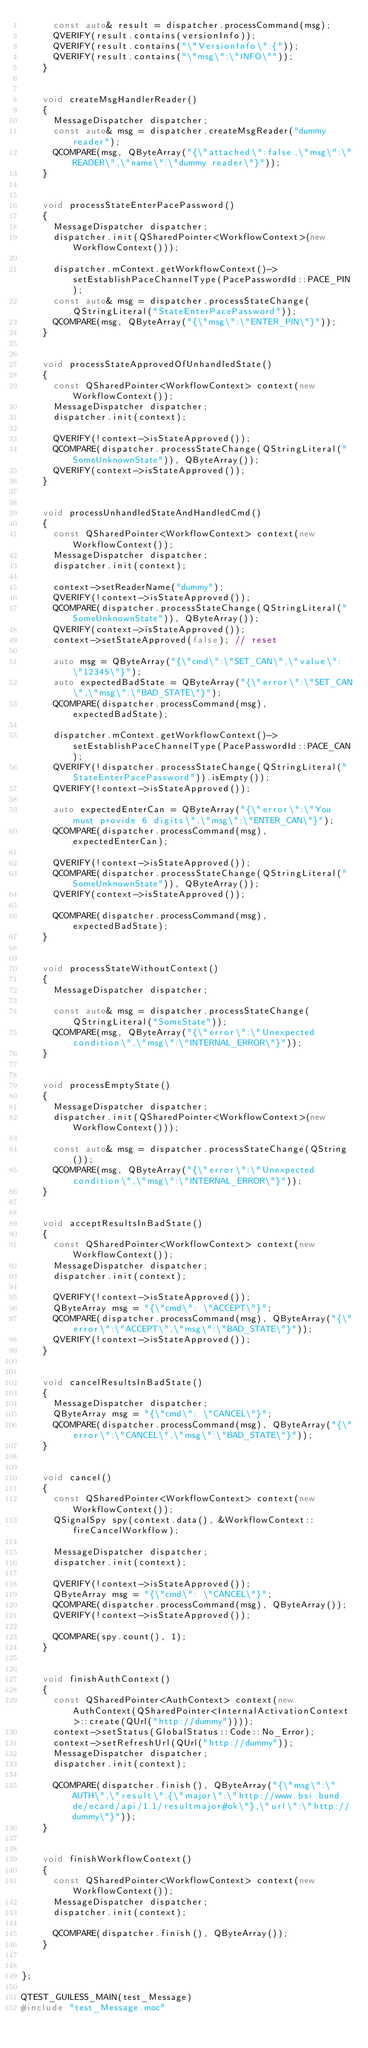<code> <loc_0><loc_0><loc_500><loc_500><_C++_>			const auto& result = dispatcher.processCommand(msg);
			QVERIFY(result.contains(versionInfo));
			QVERIFY(result.contains("\"VersionInfo\":{"));
			QVERIFY(result.contains("\"msg\":\"INFO\""));
		}


		void createMsgHandlerReader()
		{
			MessageDispatcher dispatcher;
			const auto& msg = dispatcher.createMsgReader("dummy reader");
			QCOMPARE(msg, QByteArray("{\"attached\":false,\"msg\":\"READER\",\"name\":\"dummy reader\"}"));
		}


		void processStateEnterPacePassword()
		{
			MessageDispatcher dispatcher;
			dispatcher.init(QSharedPointer<WorkflowContext>(new WorkflowContext()));

			dispatcher.mContext.getWorkflowContext()->setEstablishPaceChannelType(PacePasswordId::PACE_PIN);
			const auto& msg = dispatcher.processStateChange(QStringLiteral("StateEnterPacePassword"));
			QCOMPARE(msg, QByteArray("{\"msg\":\"ENTER_PIN\"}"));
		}


		void processStateApprovedOfUnhandledState()
		{
			const QSharedPointer<WorkflowContext> context(new WorkflowContext());
			MessageDispatcher dispatcher;
			dispatcher.init(context);

			QVERIFY(!context->isStateApproved());
			QCOMPARE(dispatcher.processStateChange(QStringLiteral("SomeUnknownState")), QByteArray());
			QVERIFY(context->isStateApproved());
		}


		void processUnhandledStateAndHandledCmd()
		{
			const QSharedPointer<WorkflowContext> context(new WorkflowContext());
			MessageDispatcher dispatcher;
			dispatcher.init(context);

			context->setReaderName("dummy");
			QVERIFY(!context->isStateApproved());
			QCOMPARE(dispatcher.processStateChange(QStringLiteral("SomeUnknownState")), QByteArray());
			QVERIFY(context->isStateApproved());
			context->setStateApproved(false); // reset

			auto msg = QByteArray("{\"cmd\":\"SET_CAN\",\"value\": \"12345\"}");
			auto expectedBadState = QByteArray("{\"error\":\"SET_CAN\",\"msg\":\"BAD_STATE\"}");
			QCOMPARE(dispatcher.processCommand(msg), expectedBadState);

			dispatcher.mContext.getWorkflowContext()->setEstablishPaceChannelType(PacePasswordId::PACE_CAN);
			QVERIFY(!dispatcher.processStateChange(QStringLiteral("StateEnterPacePassword")).isEmpty());
			QVERIFY(!context->isStateApproved());

			auto expectedEnterCan = QByteArray("{\"error\":\"You must provide 6 digits\",\"msg\":\"ENTER_CAN\"}");
			QCOMPARE(dispatcher.processCommand(msg), expectedEnterCan);

			QVERIFY(!context->isStateApproved());
			QCOMPARE(dispatcher.processStateChange(QStringLiteral("SomeUnknownState")), QByteArray());
			QVERIFY(context->isStateApproved());

			QCOMPARE(dispatcher.processCommand(msg), expectedBadState);
		}


		void processStateWithoutContext()
		{
			MessageDispatcher dispatcher;

			const auto& msg = dispatcher.processStateChange(QStringLiteral("SomeState"));
			QCOMPARE(msg, QByteArray("{\"error\":\"Unexpected condition\",\"msg\":\"INTERNAL_ERROR\"}"));
		}


		void processEmptyState()
		{
			MessageDispatcher dispatcher;
			dispatcher.init(QSharedPointer<WorkflowContext>(new WorkflowContext()));

			const auto& msg = dispatcher.processStateChange(QString());
			QCOMPARE(msg, QByteArray("{\"error\":\"Unexpected condition\",\"msg\":\"INTERNAL_ERROR\"}"));
		}


		void acceptResultsInBadState()
		{
			const QSharedPointer<WorkflowContext> context(new WorkflowContext());
			MessageDispatcher dispatcher;
			dispatcher.init(context);

			QVERIFY(!context->isStateApproved());
			QByteArray msg = "{\"cmd\": \"ACCEPT\"}";
			QCOMPARE(dispatcher.processCommand(msg), QByteArray("{\"error\":\"ACCEPT\",\"msg\":\"BAD_STATE\"}"));
			QVERIFY(!context->isStateApproved());
		}


		void cancelResultsInBadState()
		{
			MessageDispatcher dispatcher;
			QByteArray msg = "{\"cmd\": \"CANCEL\"}";
			QCOMPARE(dispatcher.processCommand(msg), QByteArray("{\"error\":\"CANCEL\",\"msg\":\"BAD_STATE\"}"));
		}


		void cancel()
		{
			const QSharedPointer<WorkflowContext> context(new WorkflowContext());
			QSignalSpy spy(context.data(), &WorkflowContext::fireCancelWorkflow);

			MessageDispatcher dispatcher;
			dispatcher.init(context);

			QVERIFY(!context->isStateApproved());
			QByteArray msg = "{\"cmd\": \"CANCEL\"}";
			QCOMPARE(dispatcher.processCommand(msg), QByteArray());
			QVERIFY(!context->isStateApproved());

			QCOMPARE(spy.count(), 1);
		}


		void finishAuthContext()
		{
			const QSharedPointer<AuthContext> context(new AuthContext(QSharedPointer<InternalActivationContext>::create(QUrl("http://dummy"))));
			context->setStatus(GlobalStatus::Code::No_Error);
			context->setRefreshUrl(QUrl("http://dummy"));
			MessageDispatcher dispatcher;
			dispatcher.init(context);

			QCOMPARE(dispatcher.finish(), QByteArray("{\"msg\":\"AUTH\",\"result\":{\"major\":\"http://www.bsi.bund.de/ecard/api/1.1/resultmajor#ok\"},\"url\":\"http://dummy\"}"));
		}


		void finishWorkflowContext()
		{
			const QSharedPointer<WorkflowContext> context(new WorkflowContext());
			MessageDispatcher dispatcher;
			dispatcher.init(context);

			QCOMPARE(dispatcher.finish(), QByteArray());
		}


};

QTEST_GUILESS_MAIN(test_Message)
#include "test_Message.moc"
</code> 